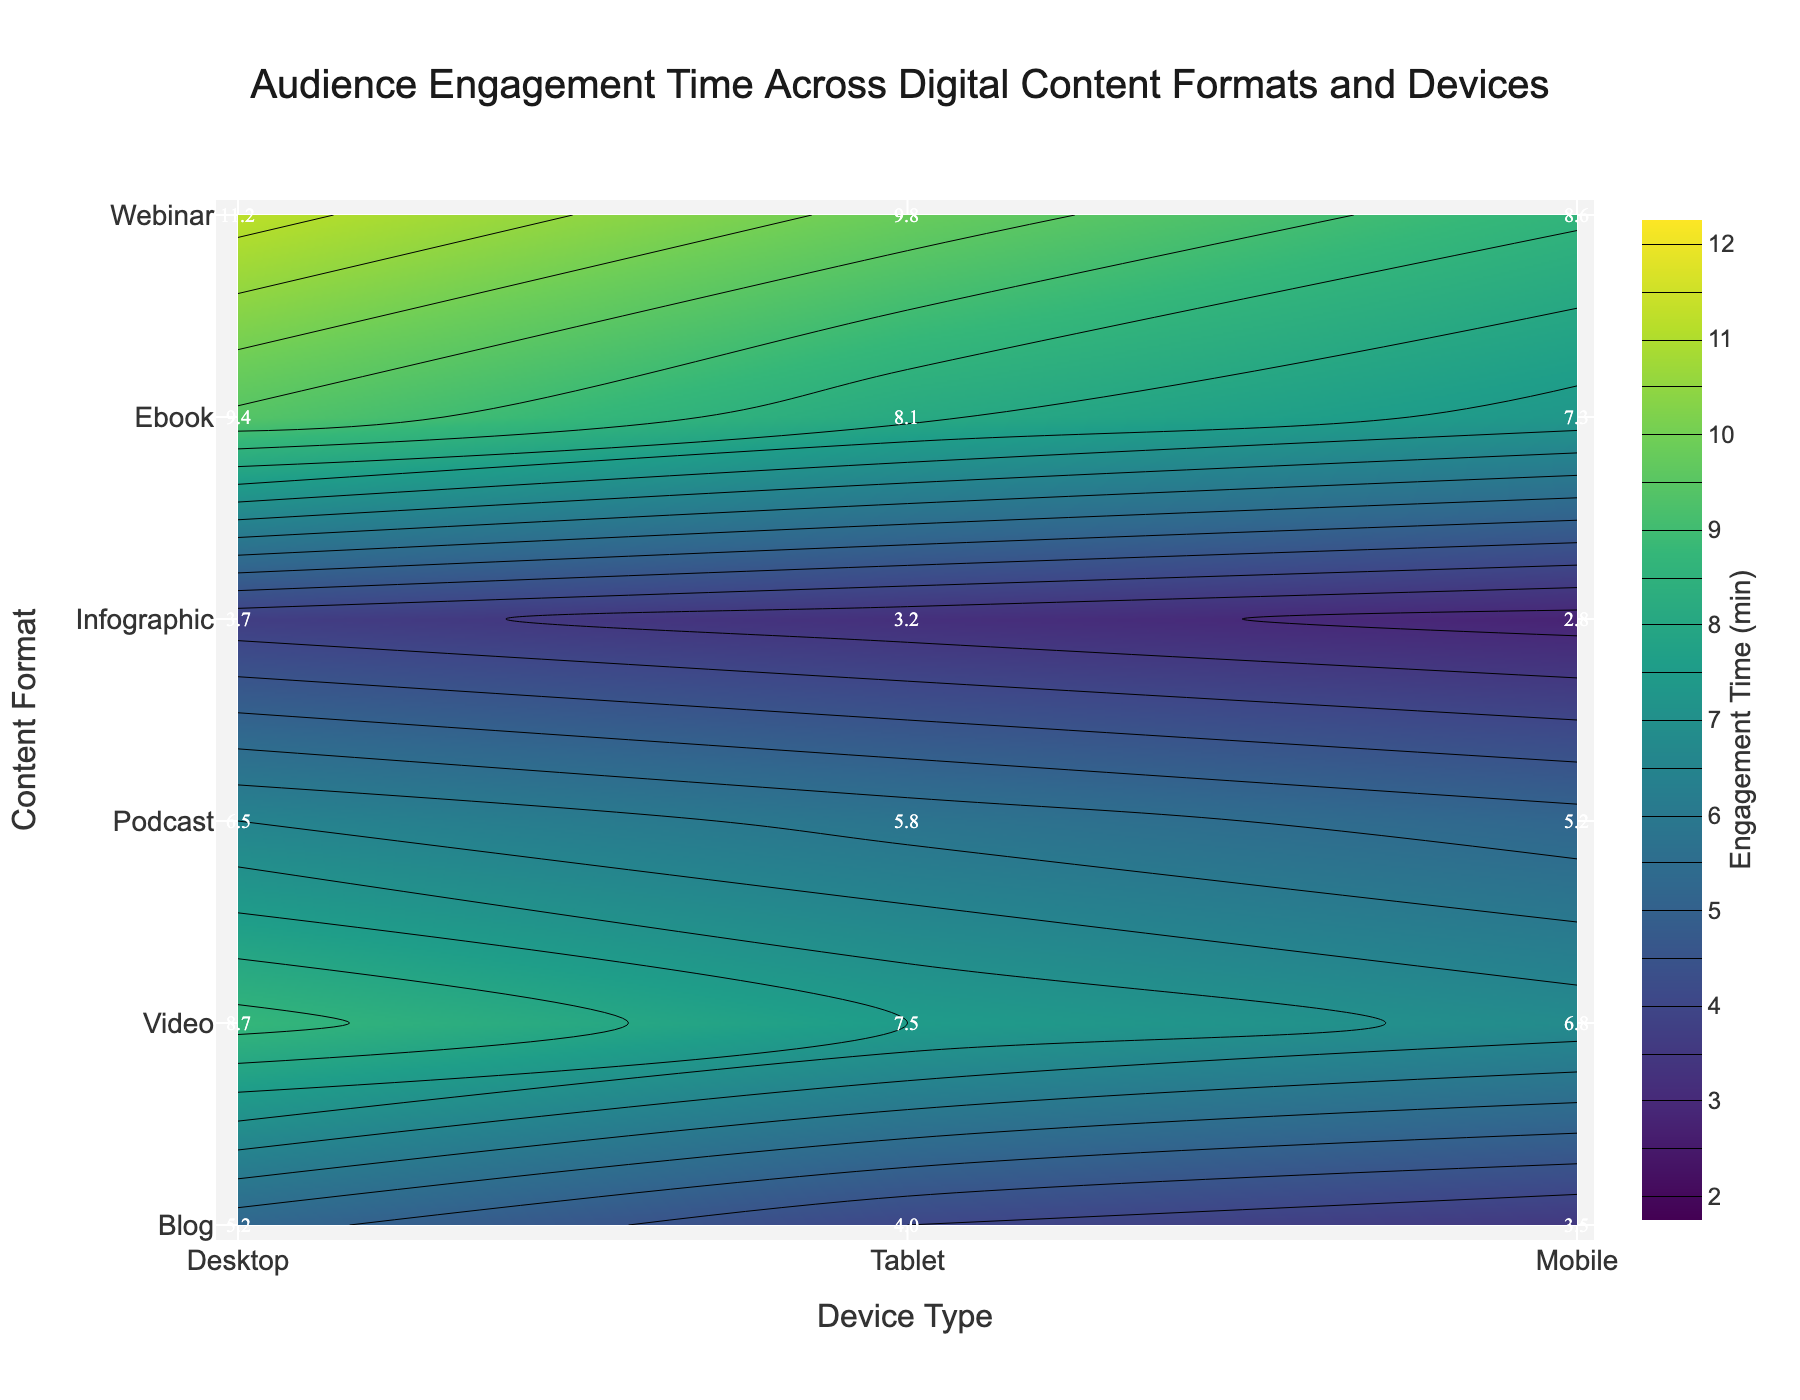What is the overall title of the figure? The title of the figure is usually displayed prominently at the top. In this case, the title is "Audience Engagement Time Across Digital Content Formats and Devices".
Answer: Audience Engagement Time Across Digital Content Formats and Devices Which device type seems to have the highest engagement time for Webinars? Locate the "Webinar" row and find the engagement time across different device types. The highest engagement time corresponds to the Desktop device type, which has a value of 11.2 minutes.
Answer: Desktop What is the engagement time for Podcasts on Mobile devices? Locate the intersection of the "Podcast" row and the "Mobile" column. The value at this point is the engagement time, which is 5.2 minutes.
Answer: 5.2 Which content format has the lowest engagement time on Tablets? By checking the engagement times for each content format on Tablets, the lowest value corresponds to Infographics with 3.2 minutes.
Answer: Infographic Compare the engagement times for Ebooks on Desktop and Mobile devices. Which one is higher, and by how much? Ebooks have engagement times of 9.4 minutes on Desktop and 7.3 minutes on Mobile. The difference is 9.4 - 7.3 = 2.1 minutes, with Desktop being higher.
Answer: Desktop, 2.1 minutes Which combination of content format and device type has the shortest engagement time? By scanning all the values, the shortest engagement time is 2.8 minutes, which corresponds to Infographics on Mobile devices.
Answer: Infographic, Mobile What is the range of engagement times for Videos across all device types? For Videos, the engagement times are 8.7 (Desktop), 7.5 (Tablet), and 6.8 (Mobile). The range is calculated as the difference between the maximum and minimum values: 8.7 - 6.8 = 1.9 minutes.
Answer: 1.9 minutes How does the engagement time for Infographics on Desktop compare to Ebooks on Tablet? Infographics on Desktop have an engagement time of 3.7 minutes, while Ebooks on Tablet have 8.1 minutes. Ebooks on Tablet have a higher engagement time.
Answer: Ebooks on Tablet Calculate the average engagement time for Webinars across all device types. Webinars have engagement times of 11.2 (Desktop), 9.8 (Tablet), and 8.6 (Mobile). The average is calculated by summing these values and dividing by the number of device types: (11.2 + 9.8 + 8.6) / 3 ≈ 9.87 minutes.
Answer: 9.87 minutes 